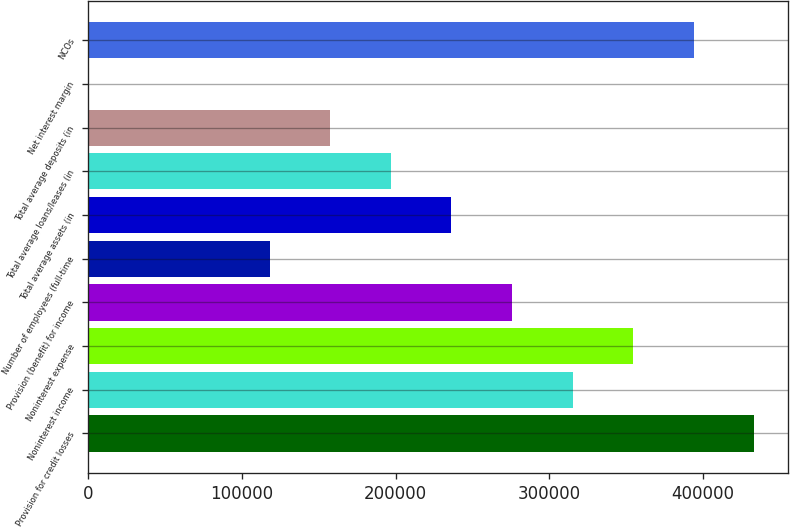Convert chart. <chart><loc_0><loc_0><loc_500><loc_500><bar_chart><fcel>Provision for credit losses<fcel>Noninterest income<fcel>Noninterest expense<fcel>Provision (benefit) for income<fcel>Number of employees (full-time<fcel>Total average assets (in<fcel>Total average loans/leases (in<fcel>Total average deposits (in<fcel>Net interest margin<fcel>NCOs<nl><fcel>433382<fcel>315188<fcel>354586<fcel>275790<fcel>118197<fcel>236391<fcel>196993<fcel>157595<fcel>2.42<fcel>393984<nl></chart> 